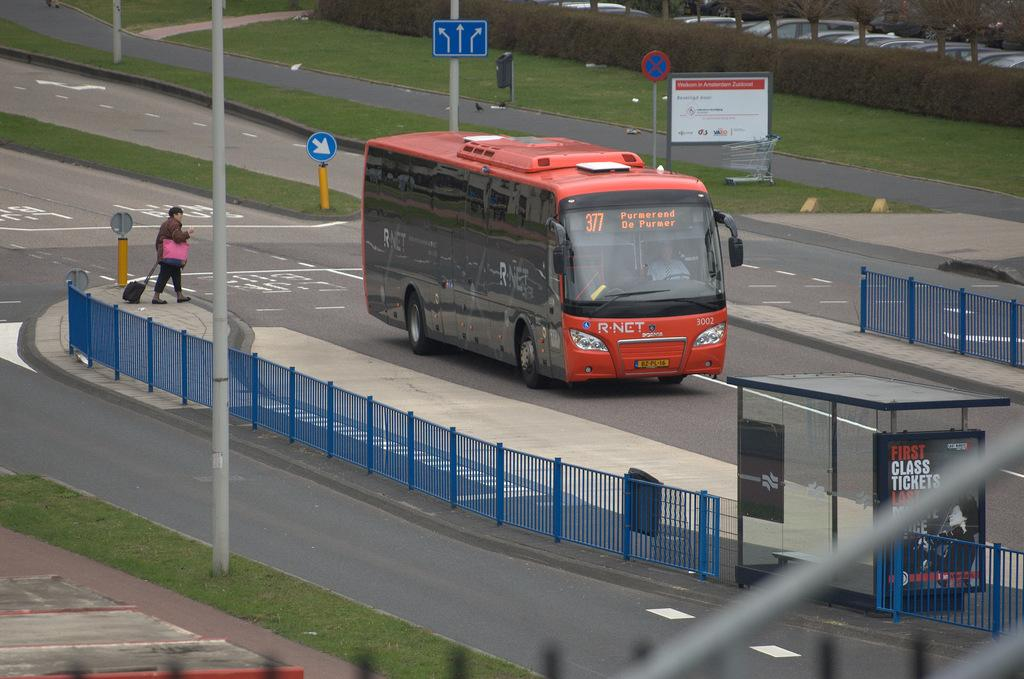What type of vehicle is on the road in the image? There is a bus on the road in the image. What can be seen in the image besides the bus? There is a fence, boards, poles, grass, plants, a person on a platform, vehicles, and trees in the image. Can you describe the person on the platform? There is a person on a platform, but no specific details about the person are provided in the facts. What is visible in the background of the image? In the background of the image, there are vehicles and trees. What type of nut is being used to open the vessel in the image? There is no nut or vessel present in the image. How many bananas are being held by the person on the platform? There is no information about bananas or the person holding them in the image. 